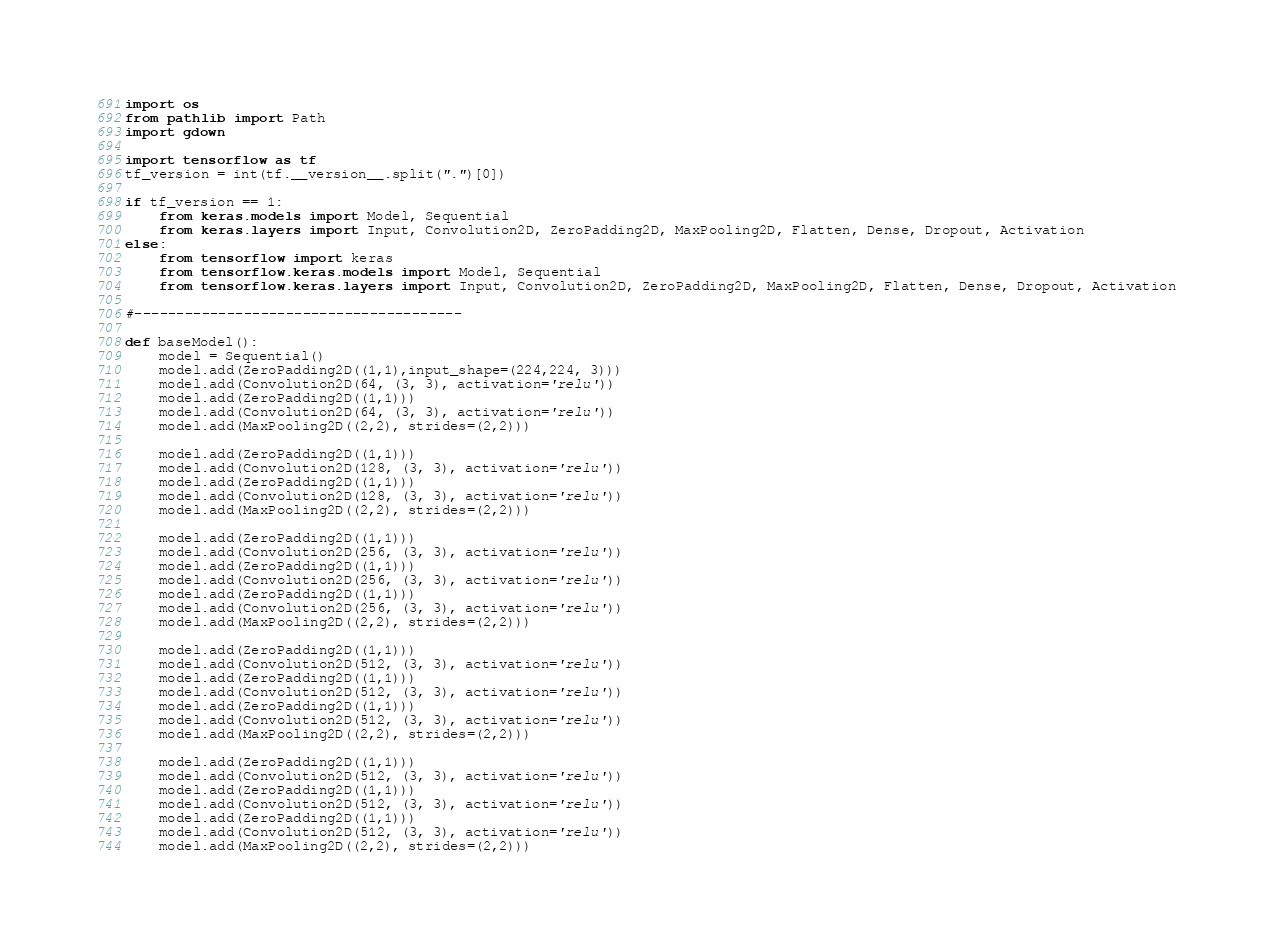<code> <loc_0><loc_0><loc_500><loc_500><_Python_>import os
from pathlib import Path
import gdown

import tensorflow as tf
tf_version = int(tf.__version__.split(".")[0])

if tf_version == 1:
	from keras.models import Model, Sequential
	from keras.layers import Input, Convolution2D, ZeroPadding2D, MaxPooling2D, Flatten, Dense, Dropout, Activation
else:
	from tensorflow import keras
	from tensorflow.keras.models import Model, Sequential
	from tensorflow.keras.layers import Input, Convolution2D, ZeroPadding2D, MaxPooling2D, Flatten, Dense, Dropout, Activation
	
#---------------------------------------

def baseModel():
	model = Sequential()
	model.add(ZeroPadding2D((1,1),input_shape=(224,224, 3)))
	model.add(Convolution2D(64, (3, 3), activation='relu'))
	model.add(ZeroPadding2D((1,1)))
	model.add(Convolution2D(64, (3, 3), activation='relu'))
	model.add(MaxPooling2D((2,2), strides=(2,2)))

	model.add(ZeroPadding2D((1,1)))
	model.add(Convolution2D(128, (3, 3), activation='relu'))
	model.add(ZeroPadding2D((1,1)))
	model.add(Convolution2D(128, (3, 3), activation='relu'))
	model.add(MaxPooling2D((2,2), strides=(2,2)))

	model.add(ZeroPadding2D((1,1)))
	model.add(Convolution2D(256, (3, 3), activation='relu'))
	model.add(ZeroPadding2D((1,1)))
	model.add(Convolution2D(256, (3, 3), activation='relu'))
	model.add(ZeroPadding2D((1,1)))
	model.add(Convolution2D(256, (3, 3), activation='relu'))
	model.add(MaxPooling2D((2,2), strides=(2,2)))

	model.add(ZeroPadding2D((1,1)))
	model.add(Convolution2D(512, (3, 3), activation='relu'))
	model.add(ZeroPadding2D((1,1)))
	model.add(Convolution2D(512, (3, 3), activation='relu'))
	model.add(ZeroPadding2D((1,1)))
	model.add(Convolution2D(512, (3, 3), activation='relu'))
	model.add(MaxPooling2D((2,2), strides=(2,2)))

	model.add(ZeroPadding2D((1,1)))
	model.add(Convolution2D(512, (3, 3), activation='relu'))
	model.add(ZeroPadding2D((1,1)))
	model.add(Convolution2D(512, (3, 3), activation='relu'))
	model.add(ZeroPadding2D((1,1)))
	model.add(Convolution2D(512, (3, 3), activation='relu'))
	model.add(MaxPooling2D((2,2), strides=(2,2)))
</code> 